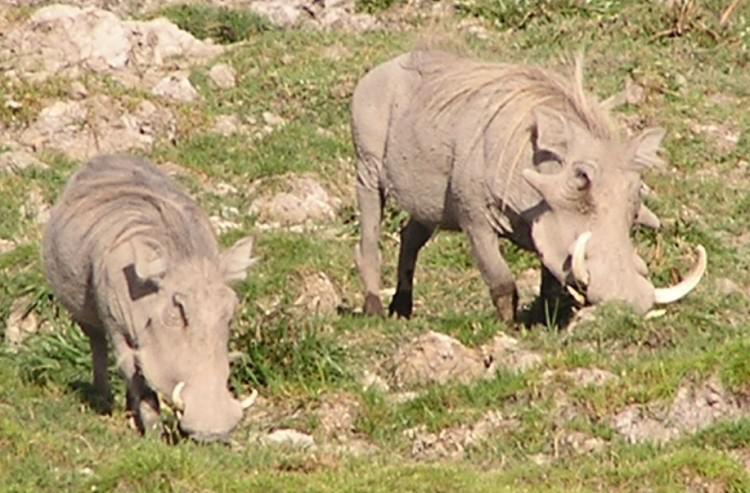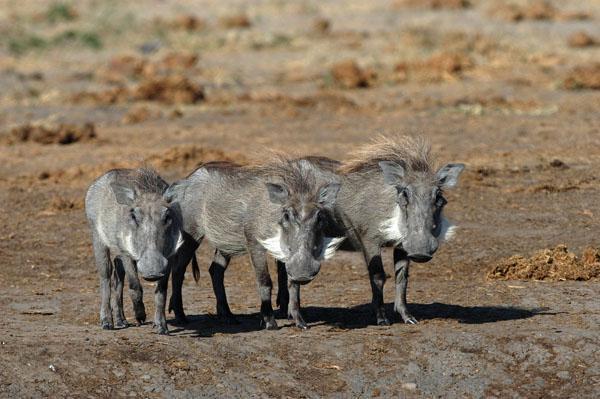The first image is the image on the left, the second image is the image on the right. For the images displayed, is the sentence "There are at most four warthogs." factually correct? Answer yes or no. No. 